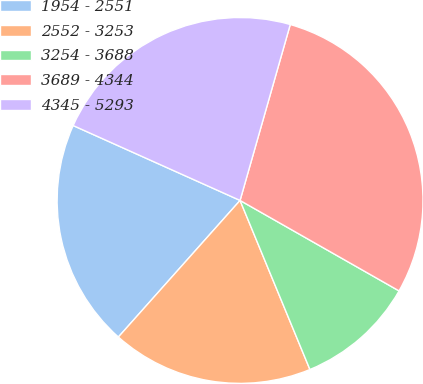Convert chart. <chart><loc_0><loc_0><loc_500><loc_500><pie_chart><fcel>1954 - 2551<fcel>2552 - 3253<fcel>3254 - 3688<fcel>3689 - 4344<fcel>4345 - 5293<nl><fcel>20.13%<fcel>17.82%<fcel>10.53%<fcel>28.81%<fcel>22.71%<nl></chart> 